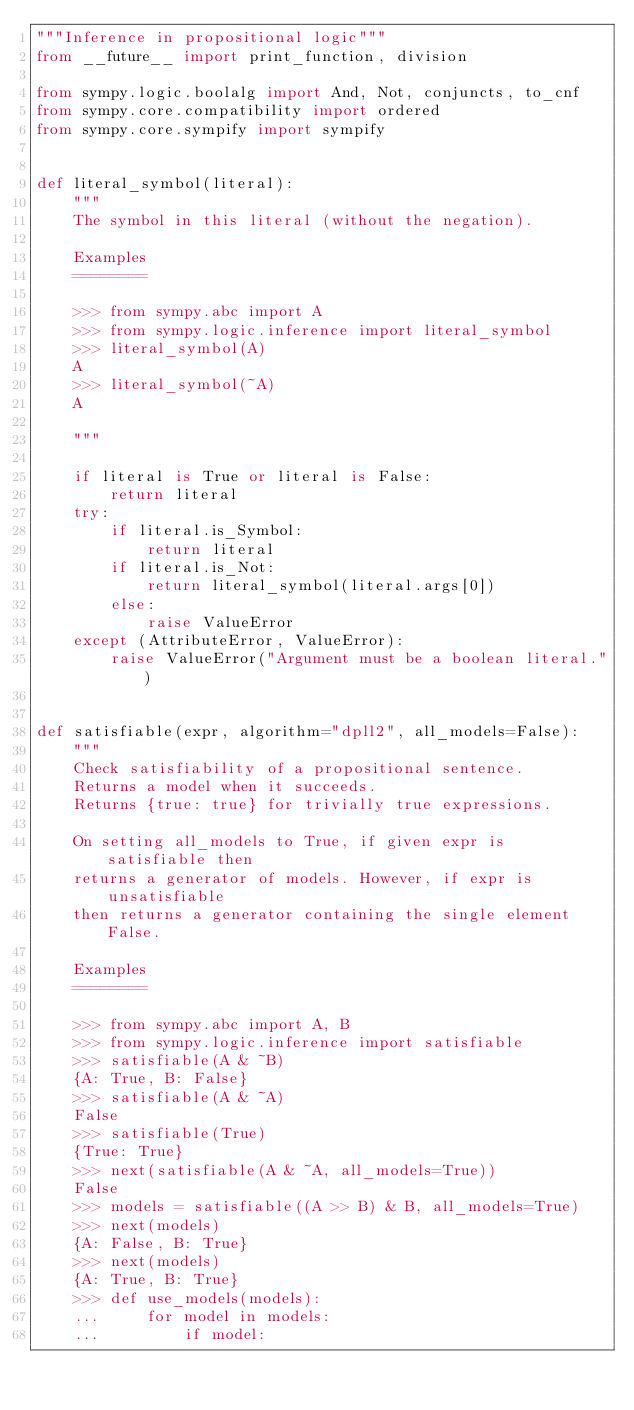Convert code to text. <code><loc_0><loc_0><loc_500><loc_500><_Python_>"""Inference in propositional logic"""
from __future__ import print_function, division

from sympy.logic.boolalg import And, Not, conjuncts, to_cnf
from sympy.core.compatibility import ordered
from sympy.core.sympify import sympify


def literal_symbol(literal):
    """
    The symbol in this literal (without the negation).

    Examples
    ========

    >>> from sympy.abc import A
    >>> from sympy.logic.inference import literal_symbol
    >>> literal_symbol(A)
    A
    >>> literal_symbol(~A)
    A

    """

    if literal is True or literal is False:
        return literal
    try:
        if literal.is_Symbol:
            return literal
        if literal.is_Not:
            return literal_symbol(literal.args[0])
        else:
            raise ValueError
    except (AttributeError, ValueError):
        raise ValueError("Argument must be a boolean literal.")


def satisfiable(expr, algorithm="dpll2", all_models=False):
    """
    Check satisfiability of a propositional sentence.
    Returns a model when it succeeds.
    Returns {true: true} for trivially true expressions.

    On setting all_models to True, if given expr is satisfiable then
    returns a generator of models. However, if expr is unsatisfiable
    then returns a generator containing the single element False.

    Examples
    ========

    >>> from sympy.abc import A, B
    >>> from sympy.logic.inference import satisfiable
    >>> satisfiable(A & ~B)
    {A: True, B: False}
    >>> satisfiable(A & ~A)
    False
    >>> satisfiable(True)
    {True: True}
    >>> next(satisfiable(A & ~A, all_models=True))
    False
    >>> models = satisfiable((A >> B) & B, all_models=True)
    >>> next(models)
    {A: False, B: True}
    >>> next(models)
    {A: True, B: True}
    >>> def use_models(models):
    ...     for model in models:
    ...         if model:</code> 